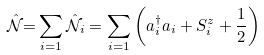Convert formula to latex. <formula><loc_0><loc_0><loc_500><loc_500>\mathcal { \hat { N } } \mathcal { = } \sum _ { i = 1 } \mathcal { \hat { N } } _ { i } = \sum _ { i = 1 } \left ( a _ { i } ^ { \dag } a _ { i } + S _ { i } ^ { z } + \frac { 1 } { 2 } \right )</formula> 